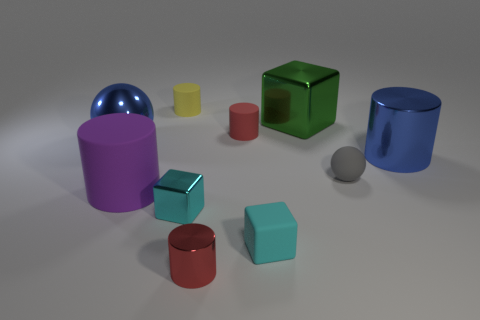Does the rubber cube have the same color as the big metallic cylinder?
Offer a very short reply. No. Is there a small metallic object of the same color as the big matte object?
Provide a short and direct response. No. Does the blue thing to the left of the big blue metal cylinder have the same material as the ball that is to the right of the red matte cylinder?
Provide a succinct answer. No. What color is the big rubber thing?
Your answer should be compact. Purple. What is the size of the red thing that is behind the big thing that is in front of the big object that is on the right side of the gray matte thing?
Provide a succinct answer. Small. How many other things are the same size as the cyan rubber thing?
Keep it short and to the point. 5. What number of big green things are made of the same material as the green block?
Provide a short and direct response. 0. What shape is the big metallic thing that is to the right of the tiny sphere?
Keep it short and to the point. Cylinder. Does the large purple object have the same material as the small red cylinder that is behind the red metallic object?
Ensure brevity in your answer.  Yes. Is there a tiny brown cylinder?
Your answer should be compact. No. 